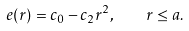<formula> <loc_0><loc_0><loc_500><loc_500>e ( r ) = c _ { 0 } - c _ { 2 } r ^ { 2 } , \quad r \leq a .</formula> 